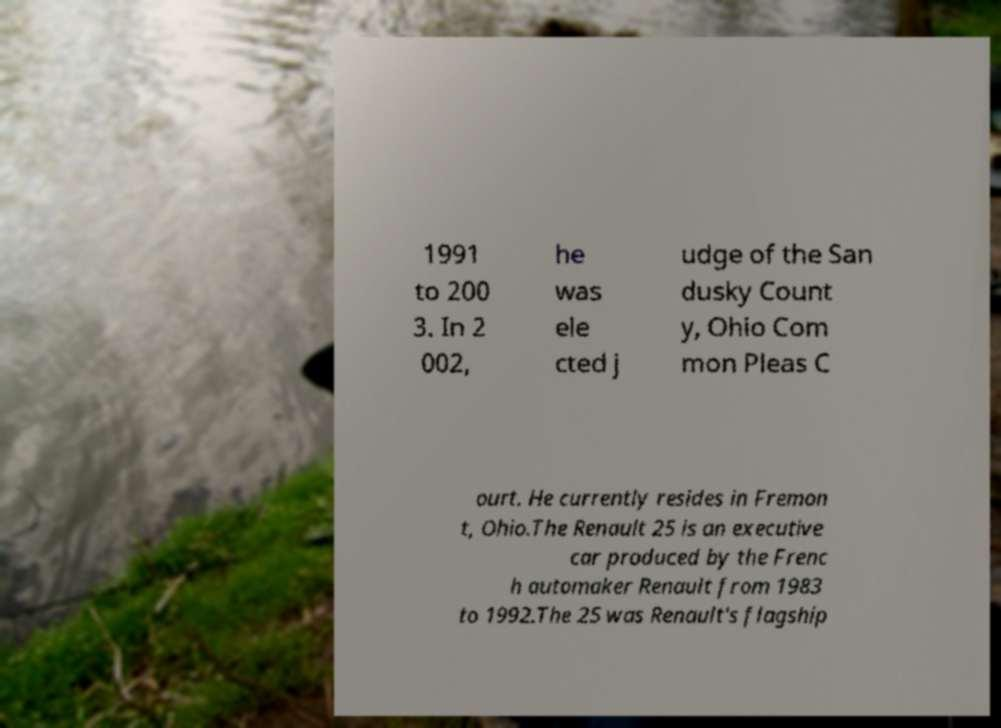Can you accurately transcribe the text from the provided image for me? 1991 to 200 3. In 2 002, he was ele cted j udge of the San dusky Count y, Ohio Com mon Pleas C ourt. He currently resides in Fremon t, Ohio.The Renault 25 is an executive car produced by the Frenc h automaker Renault from 1983 to 1992.The 25 was Renault's flagship 